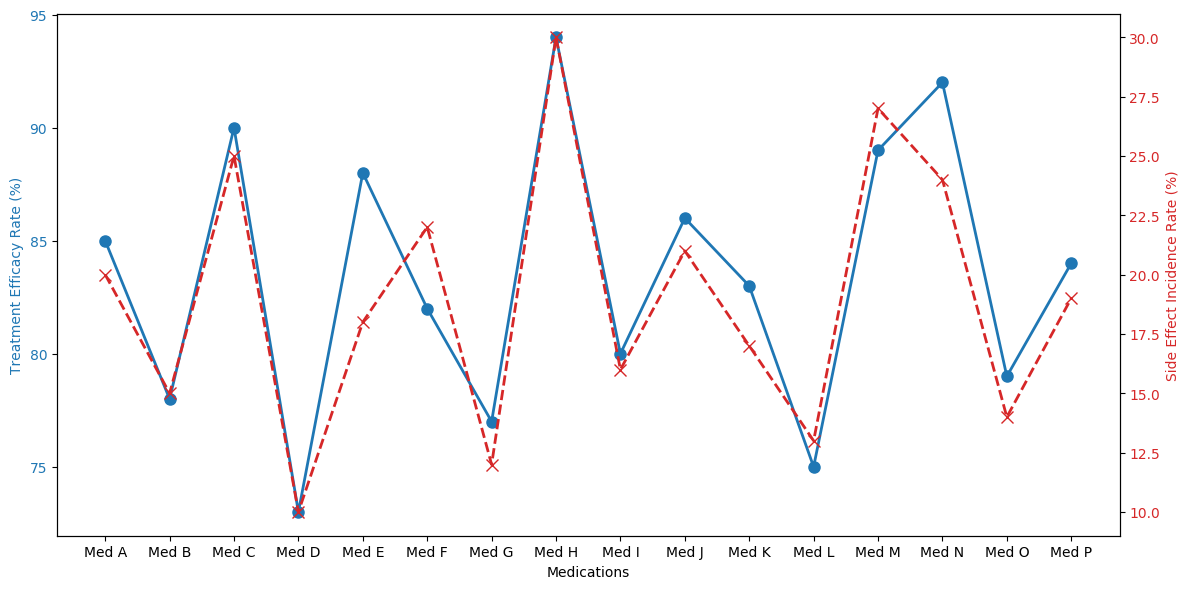Which medication has the highest treatment efficacy rate? The blue line in the figure represents the treatment efficacy rate. By looking at the peak of the blue line, we identify the highest value which corresponds to Med H.
Answer: Med H What is the difference between the treatment efficacy rates of Med H and Med G? Find the treatment efficacy rate for Med H which is 94%, and for Med G which is 77%. Subtract the latter from the former: 94 - 77.
Answer: 17% Which medication has the lowest side effect incidence rate? The red line in the figure represents the side effect incidence rate. By finding the lowest point in the red line, we identify Med D.
Answer: Med D Compare Med A and Med B: which one has a lower side effect incidence rate and by how much? The side effect incidence rates are 20% for Med A and 15% for Med B. Subtract the incidence rate of Med B from Med A: 20 - 15.
Answer: Med B, 5% Which medications have a side effect incidence rate greater than 20%? Examine the red line and identify medications where the side effect incidence rate exceeds 20%. These medications are Med C, Med F, Med H, Med M, and Med N.
Answer: Med C, Med F, Med H, Med M, Med N What is the average treatment efficacy rate of Med E, Med K, and Med P? Find the treatment efficacy rates of Med E (88%), Med K (83%), and Med P (84%). Add these values: 88 + 83 + 84, then divide by the number of medications (3): (88 + 83 + 84) / 3.
Answer: 85% How does the treatment efficacy rate of Med D compare to the side effect incidence rate of Med A? Compare the treatment efficacy rate of Med D (73%) to the side effect incidence rate of Med A (20%). The difference is calculated as 73 - 20.
Answer: 53% Which medication shows the largest gap between treatment efficacy rate and side effect incidence rate? Calculate the gap for each medication by subtracting the side effect incidence rate from the treatment efficacy rate. The largest gap is found by comparing all values. Identify Med H with a gap of 64% (94% - 30%).
Answer: Med H Calculate the total side effect incidence rate for Med B, Med D, and Med L. Sum the side effect incidence rates of Med B (15%), Med D (10%), and Med L (13%): 15 + 10 + 13.
Answer: 38% Which medication will you recommend if you prioritize high efficacy and low side effect incidence? Look for the medication with high treatment efficacy and low side effect incidence. Med H has the highest efficacy rate of 94% but a high side effect rate; however, Med E has a high efficacy (88%) and a moderate side effect rate (18%). Assessing both metrics, a balance can suggest Med E.
Answer: Med E 